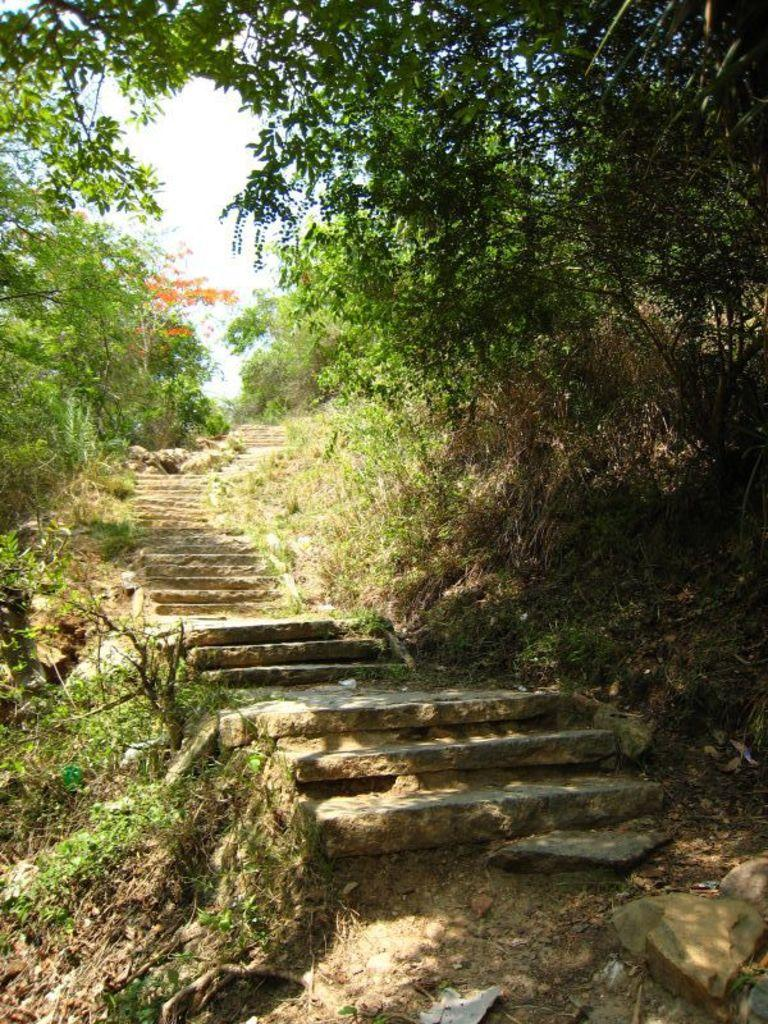What type of structure is present in the image? There is a staircase in the image. What natural elements can be seen in the image? There are trees and plants in the image. What type of terrain is visible in the image? There are rocks in the image. What is visible in the background of the image? The sky is visible in the image. What type of pest can be seen crawling on the staircase in the image? There is no pest visible on the staircase in the image. What is the bucket used for in the image? There is no bucket present in the image. 